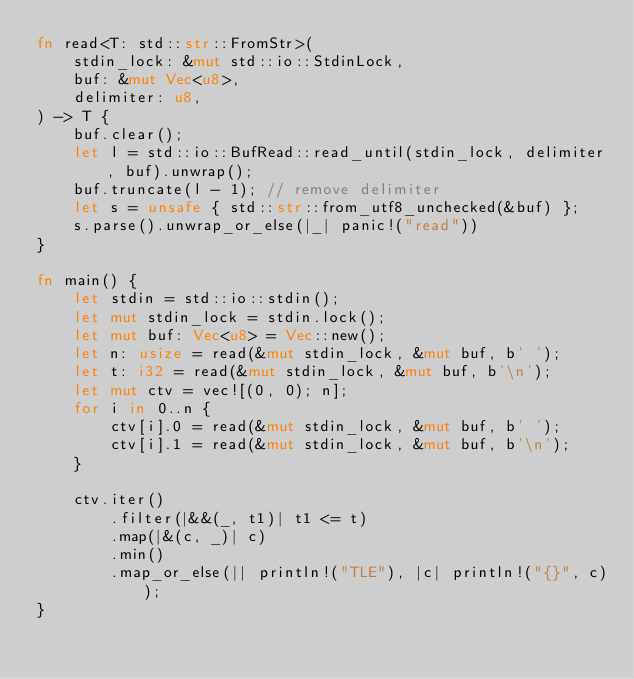<code> <loc_0><loc_0><loc_500><loc_500><_Rust_>fn read<T: std::str::FromStr>(
    stdin_lock: &mut std::io::StdinLock,
    buf: &mut Vec<u8>,
    delimiter: u8,
) -> T {
    buf.clear();
    let l = std::io::BufRead::read_until(stdin_lock, delimiter, buf).unwrap();
    buf.truncate(l - 1); // remove delimiter
    let s = unsafe { std::str::from_utf8_unchecked(&buf) };
    s.parse().unwrap_or_else(|_| panic!("read"))
}

fn main() {
    let stdin = std::io::stdin();
    let mut stdin_lock = stdin.lock();
    let mut buf: Vec<u8> = Vec::new();
    let n: usize = read(&mut stdin_lock, &mut buf, b' ');
    let t: i32 = read(&mut stdin_lock, &mut buf, b'\n');
    let mut ctv = vec![(0, 0); n];
    for i in 0..n {
        ctv[i].0 = read(&mut stdin_lock, &mut buf, b' ');
        ctv[i].1 = read(&mut stdin_lock, &mut buf, b'\n');
    }

    ctv.iter()
        .filter(|&&(_, t1)| t1 <= t)
        .map(|&(c, _)| c)
        .min()
        .map_or_else(|| println!("TLE"), |c| println!("{}", c));
}
</code> 